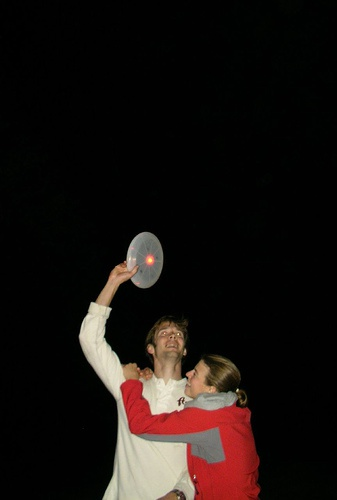Describe the objects in this image and their specific colors. I can see people in black, beige, darkgray, and gray tones, people in black, brown, and gray tones, and frisbee in black, gray, and darkgray tones in this image. 